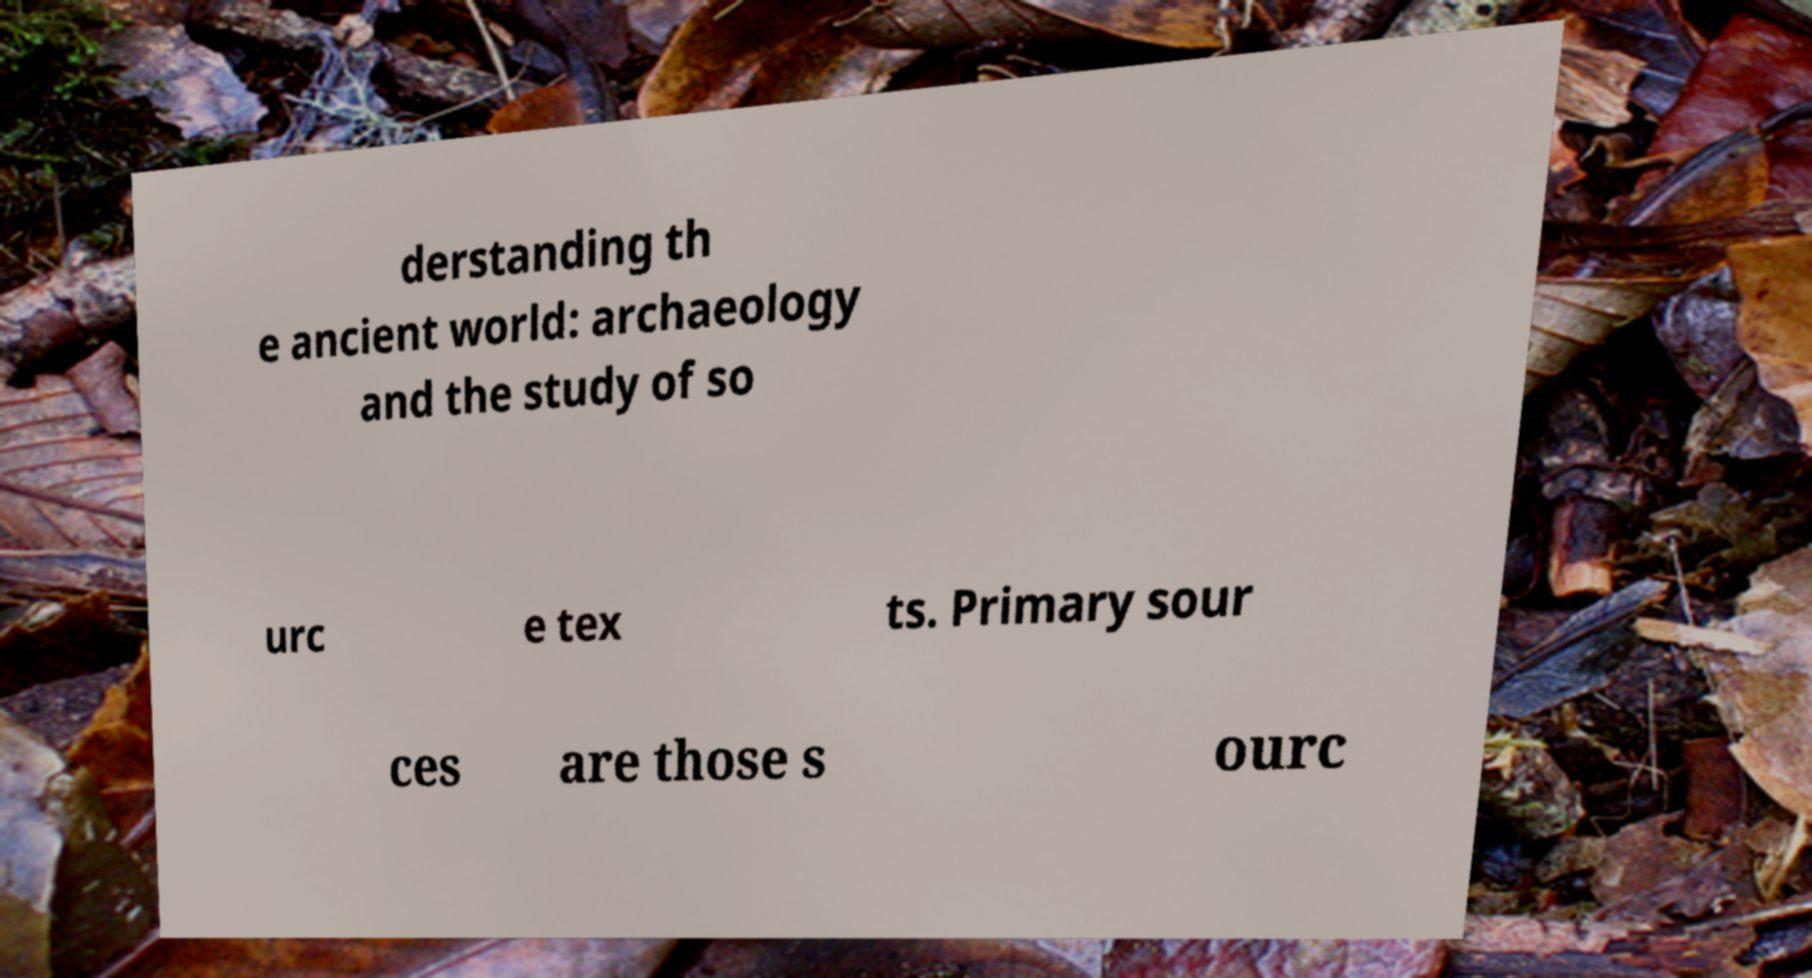Please identify and transcribe the text found in this image. derstanding th e ancient world: archaeology and the study of so urc e tex ts. Primary sour ces are those s ourc 